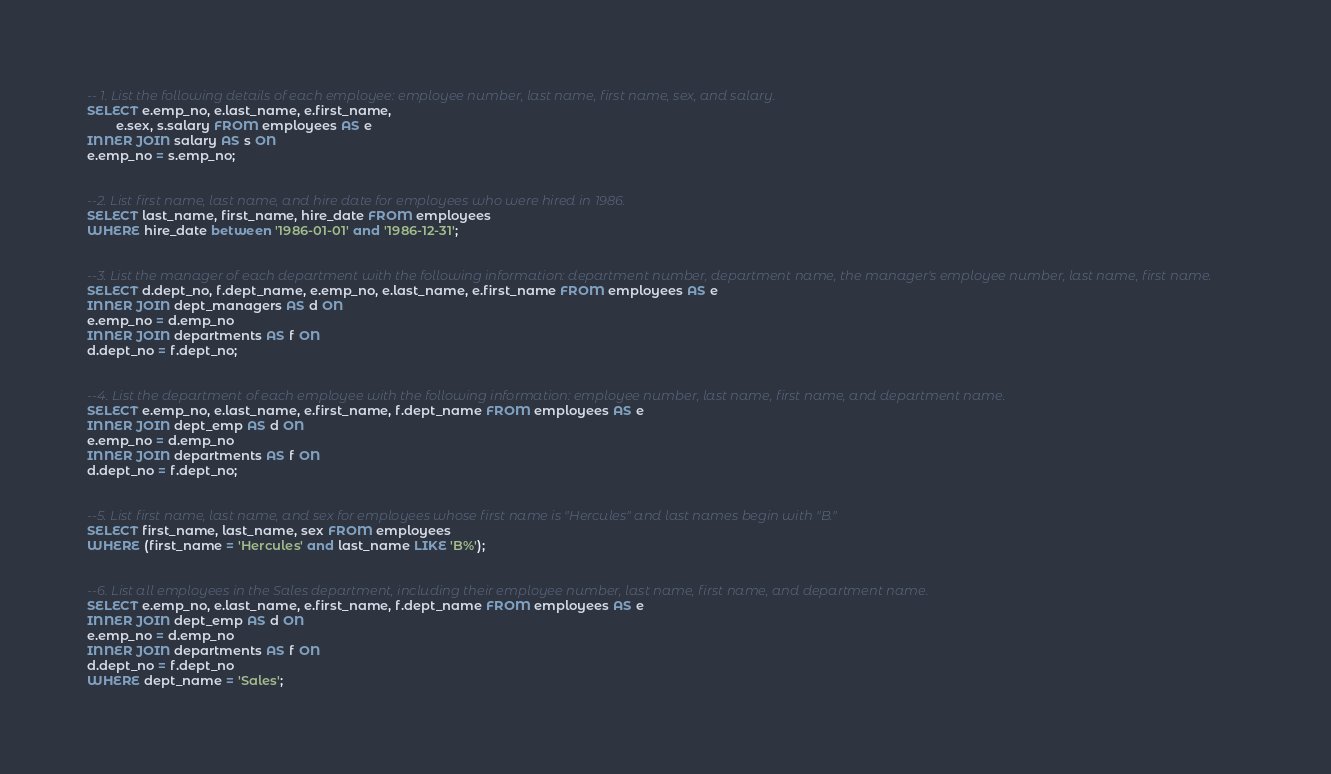<code> <loc_0><loc_0><loc_500><loc_500><_SQL_>-- 1. List the following details of each employee: employee number, last name, first name, sex, and salary.
SELECT e.emp_no, e.last_name, e.first_name, 
		e.sex, s.salary FROM employees AS e
INNER JOIN salary AS s ON
e.emp_no = s.emp_no;


--2. List first name, last name, and hire date for employees who were hired in 1986.
SELECT last_name, first_name, hire_date FROM employees
WHERE hire_date between '1986-01-01' and '1986-12-31';


--3. List the manager of each department with the following information: department number, department name, the manager's employee number, last name, first name.
SELECT d.dept_no, f.dept_name, e.emp_no, e.last_name, e.first_name FROM employees AS e
INNER JOIN dept_managers AS d ON
e.emp_no = d.emp_no
INNER JOIN departments AS f ON
d.dept_no = f.dept_no;


--4. List the department of each employee with the following information: employee number, last name, first name, and department name.
SELECT e.emp_no, e.last_name, e.first_name, f.dept_name FROM employees AS e
INNER JOIN dept_emp AS d ON
e.emp_no = d.emp_no
INNER JOIN departments AS f ON
d.dept_no = f.dept_no;


--5. List first name, last name, and sex for employees whose first name is "Hercules" and last names begin with "B."
SELECT first_name, last_name, sex FROM employees
WHERE (first_name = 'Hercules' and last_name LIKE 'B%');


--6. List all employees in the Sales department, including their employee number, last name, first name, and department name.
SELECT e.emp_no, e.last_name, e.first_name, f.dept_name FROM employees AS e
INNER JOIN dept_emp AS d ON
e.emp_no = d.emp_no
INNER JOIN departments AS f ON
d.dept_no = f.dept_no
WHERE dept_name = 'Sales';

</code> 